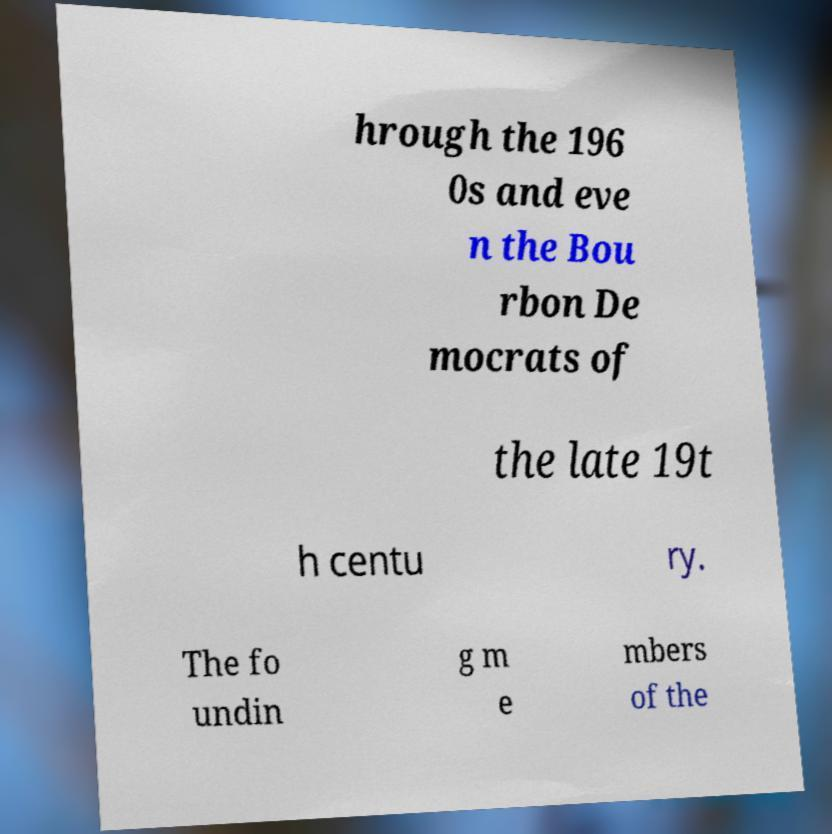What messages or text are displayed in this image? I need them in a readable, typed format. hrough the 196 0s and eve n the Bou rbon De mocrats of the late 19t h centu ry. The fo undin g m e mbers of the 